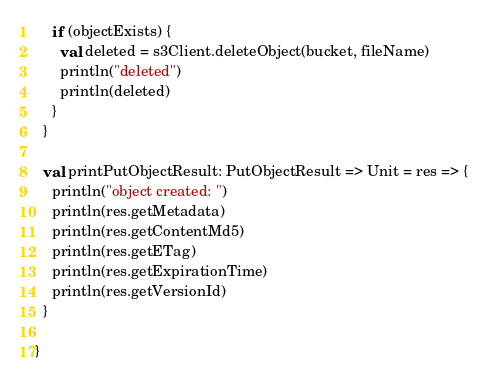Convert code to text. <code><loc_0><loc_0><loc_500><loc_500><_Scala_>    if (objectExists) {
      val deleted = s3Client.deleteObject(bucket, fileName)
      println("deleted")
      println(deleted)
    }
  }

  val printPutObjectResult: PutObjectResult => Unit = res => {
    println("object created: ")
    println(res.getMetadata)
    println(res.getContentMd5)
    println(res.getETag)
    println(res.getExpirationTime)
    println(res.getVersionId)
  }

}
</code> 